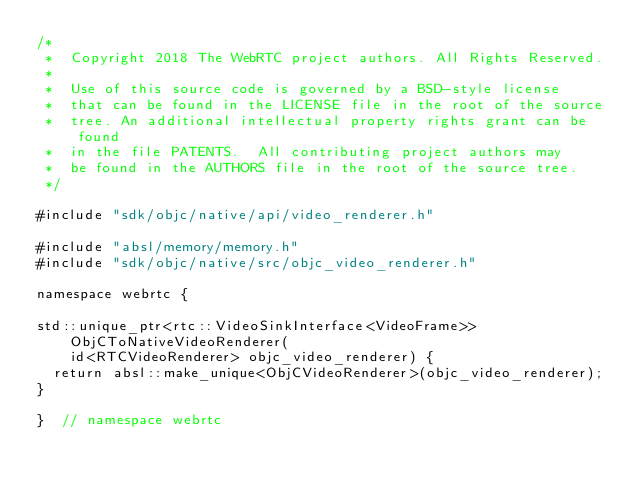<code> <loc_0><loc_0><loc_500><loc_500><_ObjectiveC_>/*
 *  Copyright 2018 The WebRTC project authors. All Rights Reserved.
 *
 *  Use of this source code is governed by a BSD-style license
 *  that can be found in the LICENSE file in the root of the source
 *  tree. An additional intellectual property rights grant can be found
 *  in the file PATENTS.  All contributing project authors may
 *  be found in the AUTHORS file in the root of the source tree.
 */

#include "sdk/objc/native/api/video_renderer.h"

#include "absl/memory/memory.h"
#include "sdk/objc/native/src/objc_video_renderer.h"

namespace webrtc {

std::unique_ptr<rtc::VideoSinkInterface<VideoFrame>> ObjCToNativeVideoRenderer(
    id<RTCVideoRenderer> objc_video_renderer) {
  return absl::make_unique<ObjCVideoRenderer>(objc_video_renderer);
}

}  // namespace webrtc
</code> 